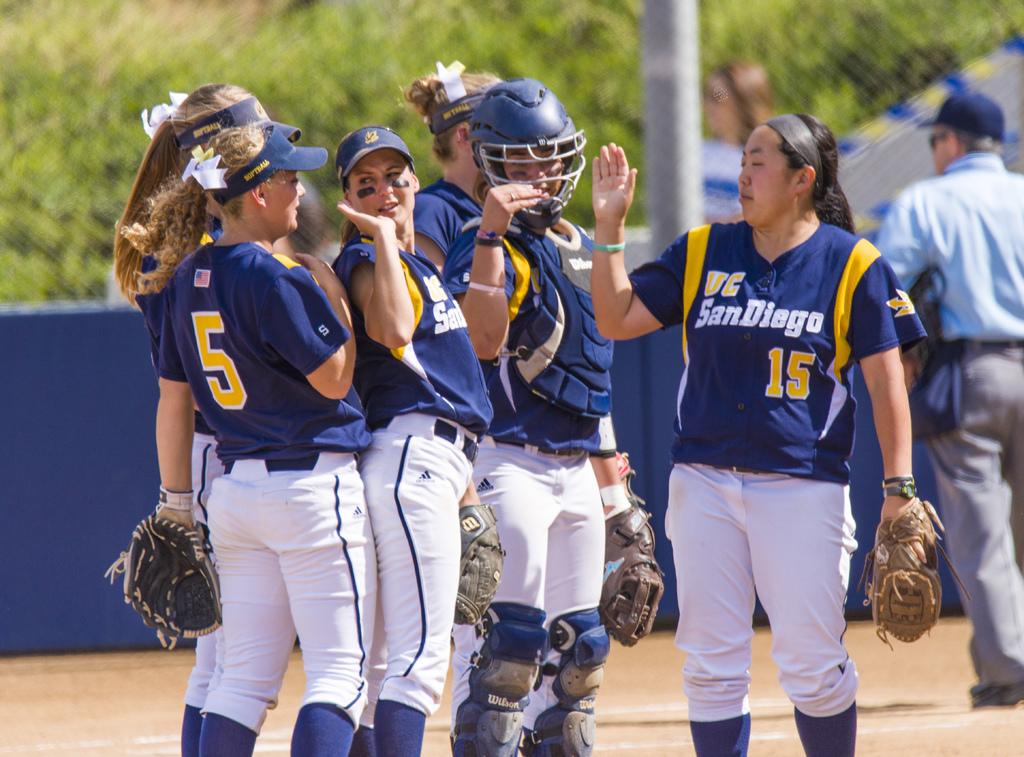Does the number 5 appear on any of the girls jerseys?
Provide a short and direct response. Yes. What team are they on?
Your response must be concise. San diego. 